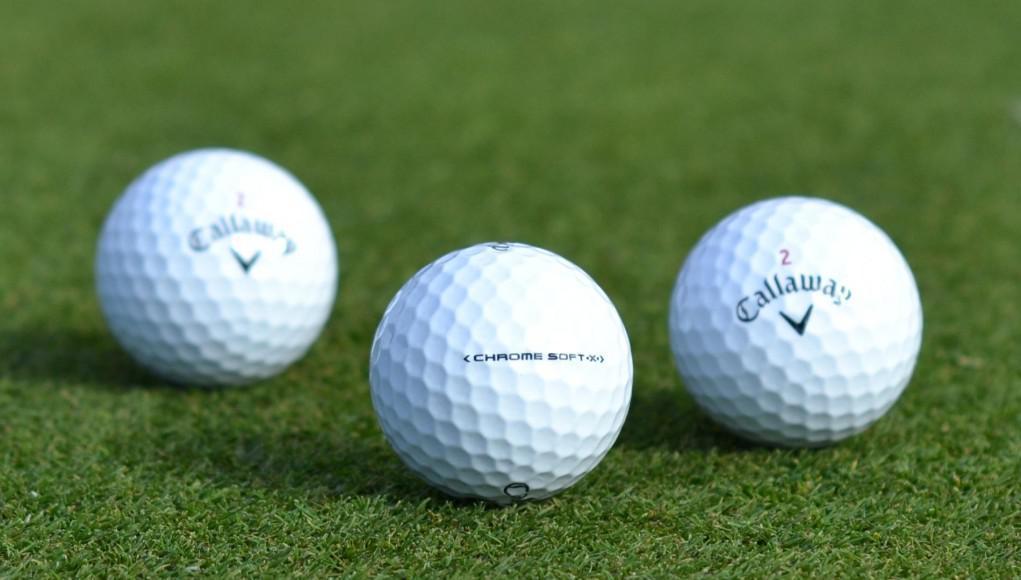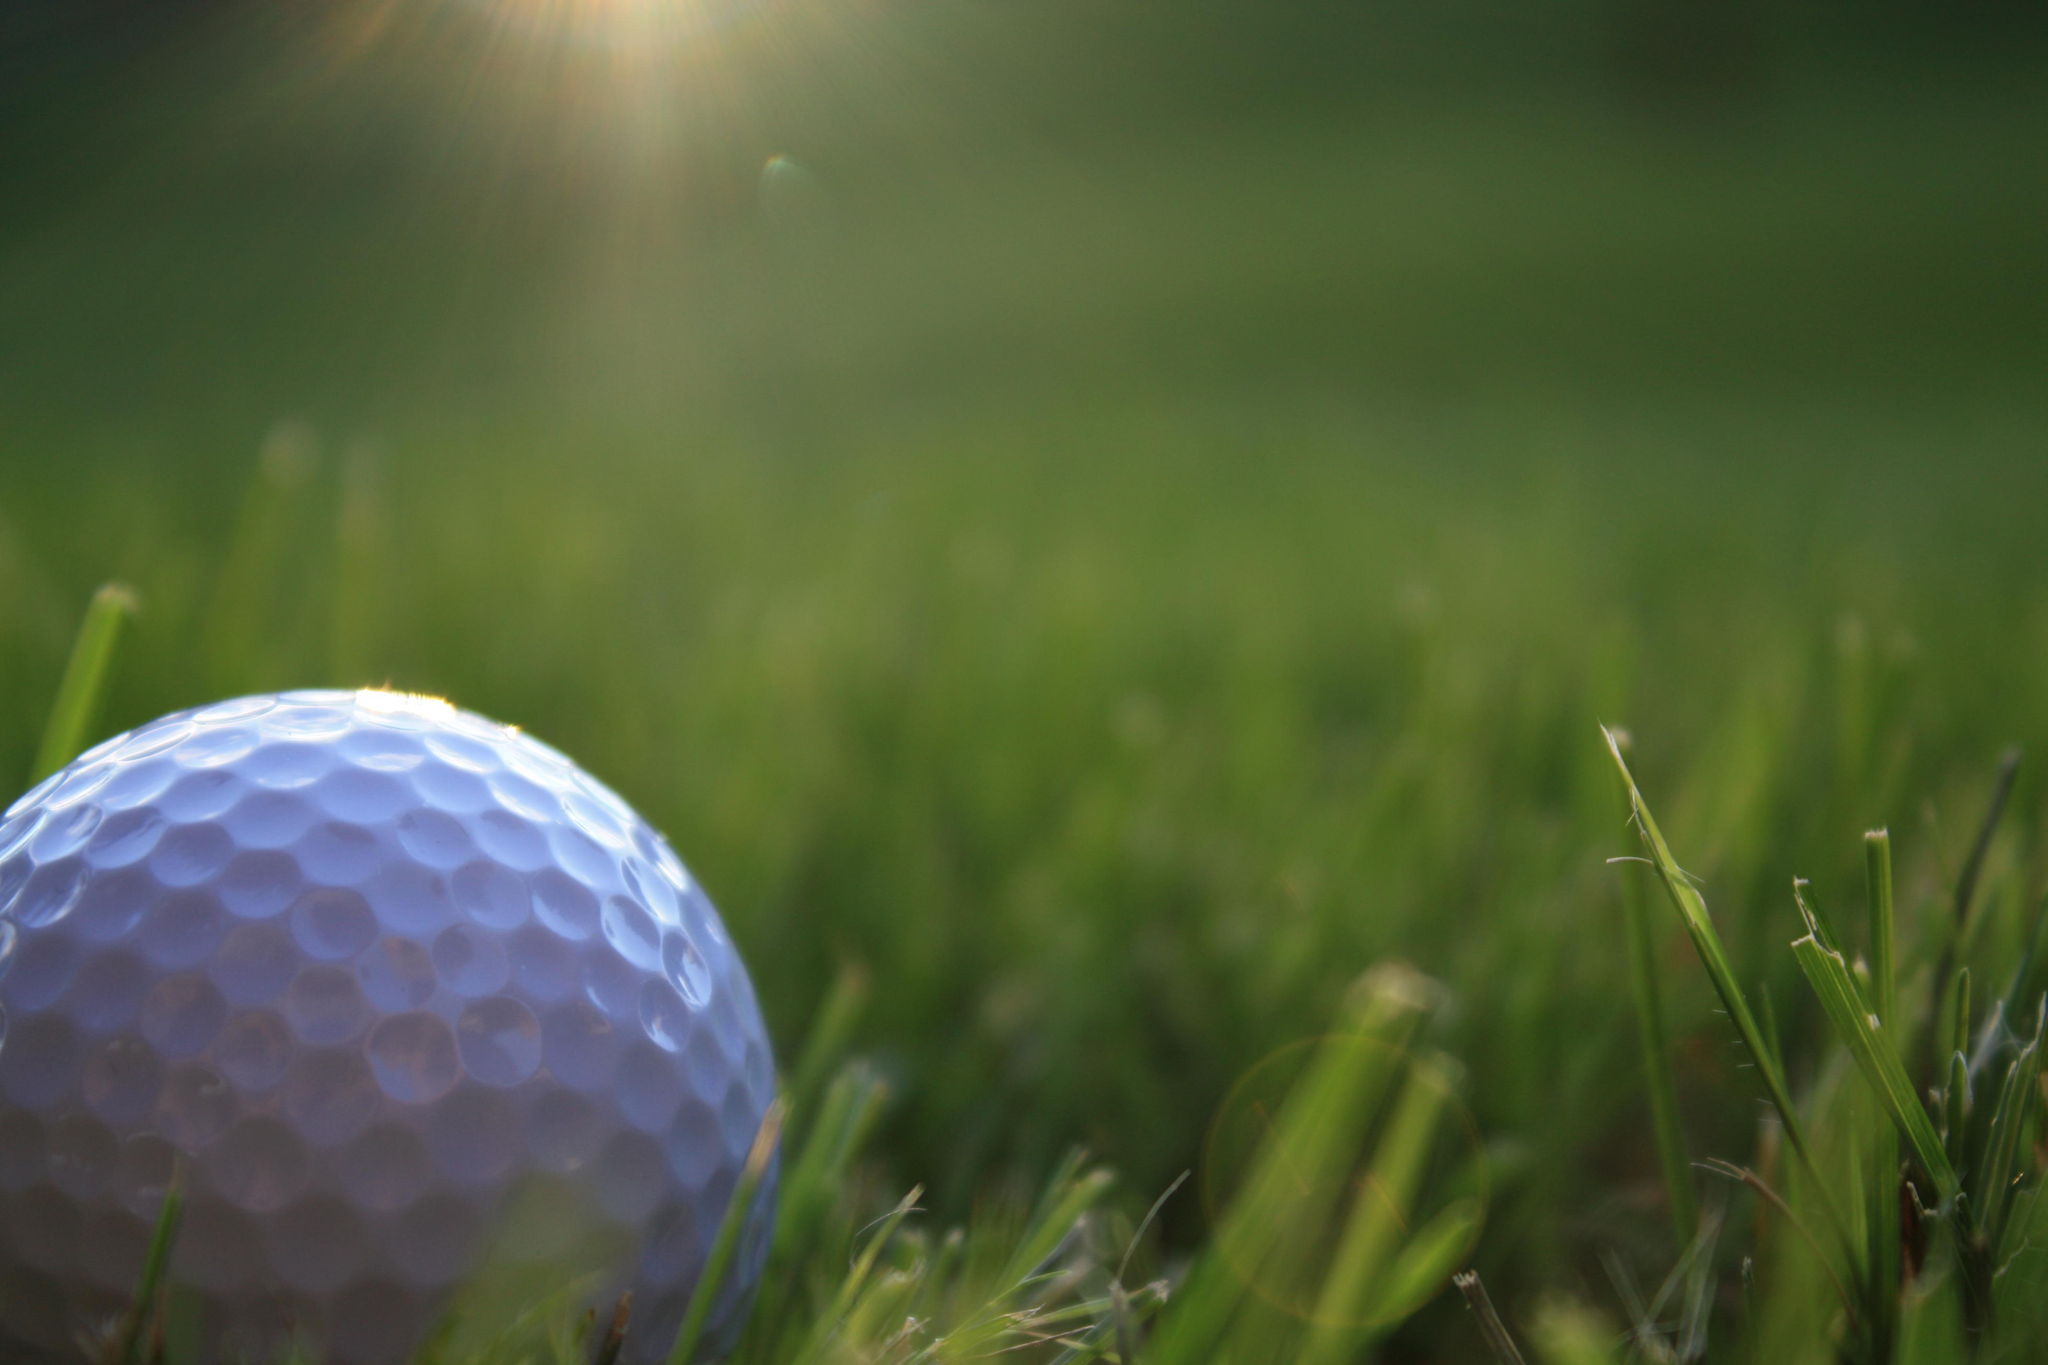The first image is the image on the left, the second image is the image on the right. Analyze the images presented: Is the assertion "All golf balls are sitting on tees in grassy areas." valid? Answer yes or no. No. 